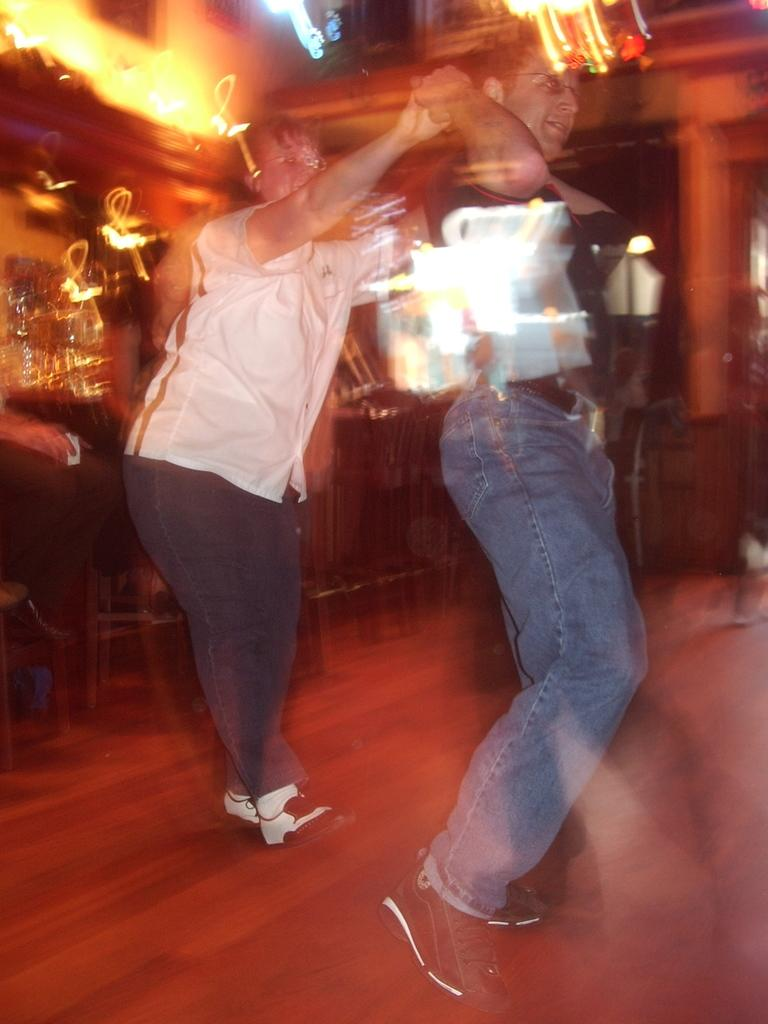What are the two persons in the image doing? The two persons in the image are dancing. Where is the dancing taking place? The dancing is taking place on the floor. Can you describe the background of the image? There is a person visible in the background of the image, along with lights and objects. What type of spark can be seen coming from the nation in the image? There is no mention of a nation or spark in the image; it features two persons dancing on the floor with a background that includes a person, lights, and objects. 